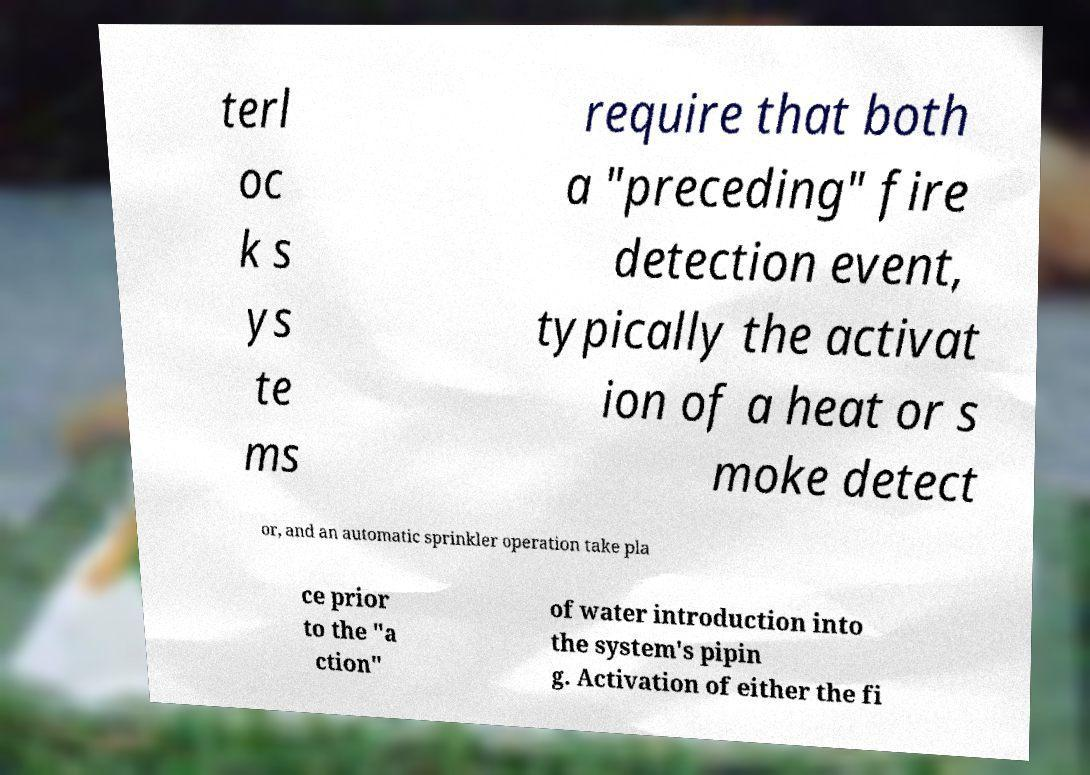Please read and relay the text visible in this image. What does it say? terl oc k s ys te ms require that both a "preceding" fire detection event, typically the activat ion of a heat or s moke detect or, and an automatic sprinkler operation take pla ce prior to the "a ction" of water introduction into the system's pipin g. Activation of either the fi 